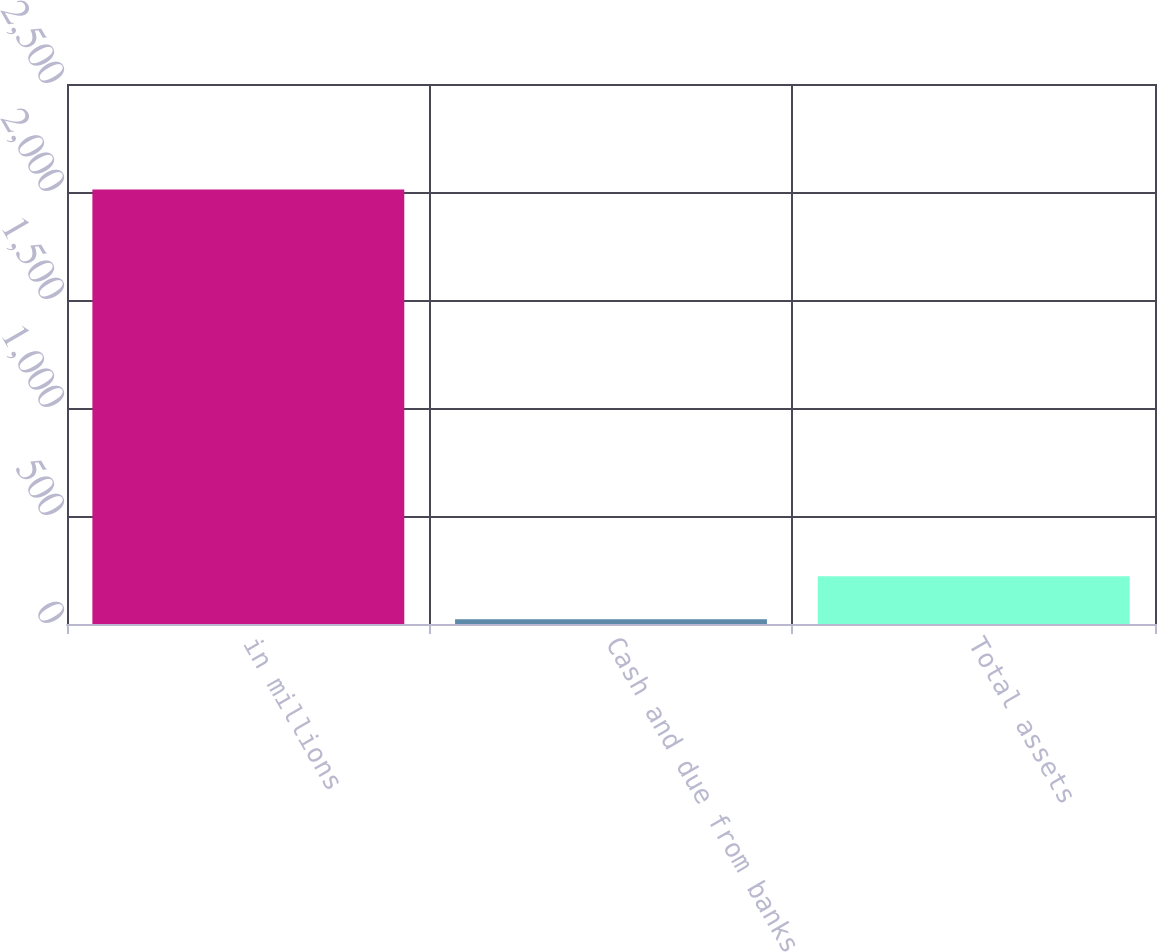<chart> <loc_0><loc_0><loc_500><loc_500><bar_chart><fcel>in millions<fcel>Cash and due from banks<fcel>Total assets<nl><fcel>2012<fcel>22<fcel>221<nl></chart> 